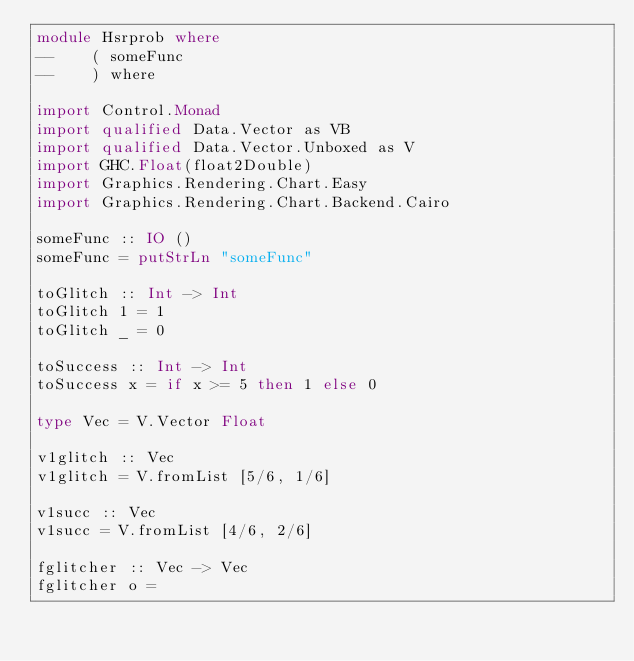Convert code to text. <code><loc_0><loc_0><loc_500><loc_500><_Haskell_>module Hsrprob where
--    ( someFunc
--    ) where

import Control.Monad
import qualified Data.Vector as VB
import qualified Data.Vector.Unboxed as V
import GHC.Float(float2Double)
import Graphics.Rendering.Chart.Easy
import Graphics.Rendering.Chart.Backend.Cairo

someFunc :: IO ()
someFunc = putStrLn "someFunc"

toGlitch :: Int -> Int
toGlitch 1 = 1
toGlitch _ = 0

toSuccess :: Int -> Int
toSuccess x = if x >= 5 then 1 else 0

type Vec = V.Vector Float

v1glitch :: Vec
v1glitch = V.fromList [5/6, 1/6]

v1succ :: Vec
v1succ = V.fromList [4/6, 2/6]

fglitcher :: Vec -> Vec
fglitcher o =</code> 